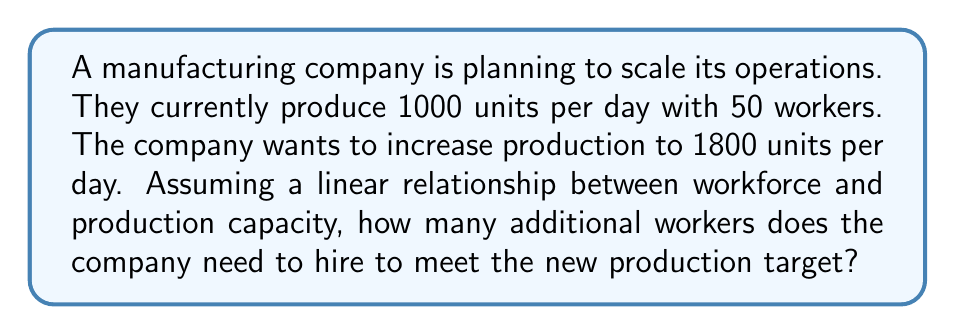Show me your answer to this math problem. Let's approach this step-by-step:

1) First, let's establish the current relationship between workers and production:
   $\frac{1000 \text{ units}}{50 \text{ workers}} = 20 \text{ units per worker per day}$

2) We can express this as a linear equation:
   $P = 20W$, where $P$ is production and $W$ is the number of workers.

3) Now, we want to find $W$ when $P = 1800$:
   $1800 = 20W$

4) Solving for $W$:
   $W = \frac{1800}{20} = 90$

5) This means we need 90 workers total for the new production target.

6) To find the number of additional workers needed:
   Additional workers = New total workers - Current workers
   $= 90 - 50 = 40$

Therefore, the company needs to hire 40 additional workers to meet the new production target of 1800 units per day.
Answer: 40 workers 